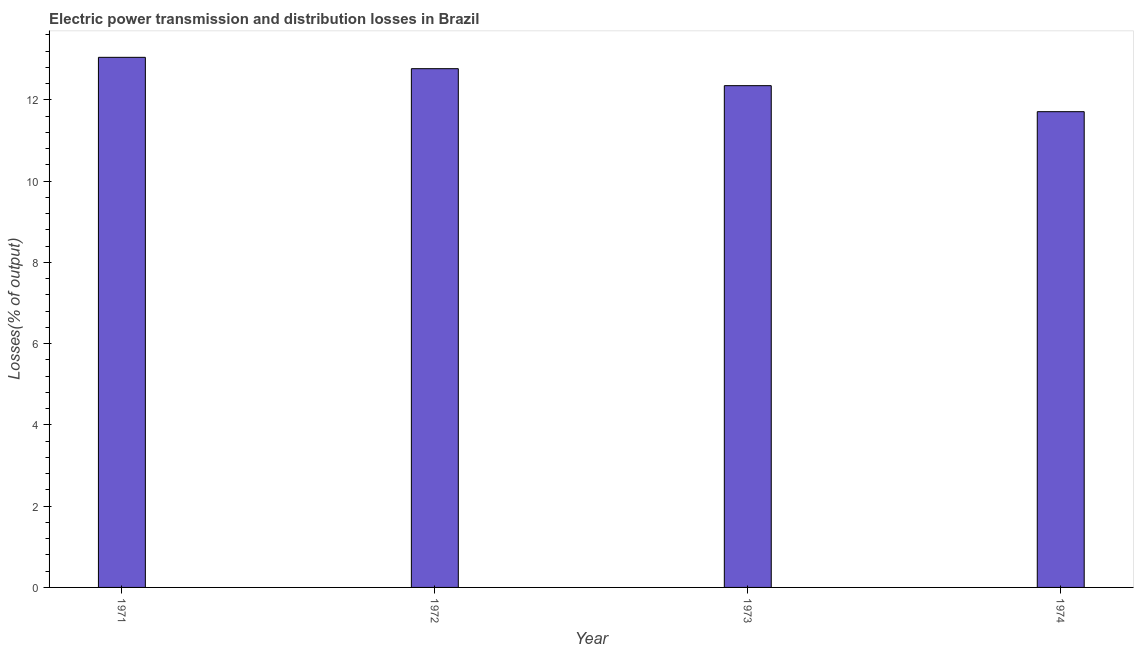Does the graph contain grids?
Your answer should be very brief. No. What is the title of the graph?
Offer a very short reply. Electric power transmission and distribution losses in Brazil. What is the label or title of the X-axis?
Offer a very short reply. Year. What is the label or title of the Y-axis?
Give a very brief answer. Losses(% of output). What is the electric power transmission and distribution losses in 1972?
Offer a very short reply. 12.77. Across all years, what is the maximum electric power transmission and distribution losses?
Offer a terse response. 13.05. Across all years, what is the minimum electric power transmission and distribution losses?
Keep it short and to the point. 11.71. In which year was the electric power transmission and distribution losses maximum?
Your answer should be very brief. 1971. In which year was the electric power transmission and distribution losses minimum?
Your answer should be compact. 1974. What is the sum of the electric power transmission and distribution losses?
Offer a very short reply. 49.87. What is the difference between the electric power transmission and distribution losses in 1971 and 1972?
Make the answer very short. 0.28. What is the average electric power transmission and distribution losses per year?
Your answer should be very brief. 12.47. What is the median electric power transmission and distribution losses?
Give a very brief answer. 12.56. In how many years, is the electric power transmission and distribution losses greater than 7.2 %?
Keep it short and to the point. 4. What is the ratio of the electric power transmission and distribution losses in 1972 to that in 1974?
Offer a terse response. 1.09. Is the difference between the electric power transmission and distribution losses in 1971 and 1974 greater than the difference between any two years?
Keep it short and to the point. Yes. What is the difference between the highest and the second highest electric power transmission and distribution losses?
Ensure brevity in your answer.  0.28. What is the difference between the highest and the lowest electric power transmission and distribution losses?
Ensure brevity in your answer.  1.34. How many bars are there?
Your answer should be very brief. 4. Are the values on the major ticks of Y-axis written in scientific E-notation?
Make the answer very short. No. What is the Losses(% of output) of 1971?
Keep it short and to the point. 13.05. What is the Losses(% of output) in 1972?
Make the answer very short. 12.77. What is the Losses(% of output) of 1973?
Make the answer very short. 12.35. What is the Losses(% of output) of 1974?
Provide a succinct answer. 11.71. What is the difference between the Losses(% of output) in 1971 and 1972?
Your answer should be compact. 0.28. What is the difference between the Losses(% of output) in 1971 and 1973?
Your response must be concise. 0.7. What is the difference between the Losses(% of output) in 1971 and 1974?
Your answer should be very brief. 1.34. What is the difference between the Losses(% of output) in 1972 and 1973?
Give a very brief answer. 0.42. What is the difference between the Losses(% of output) in 1972 and 1974?
Ensure brevity in your answer.  1.06. What is the difference between the Losses(% of output) in 1973 and 1974?
Your answer should be compact. 0.64. What is the ratio of the Losses(% of output) in 1971 to that in 1973?
Ensure brevity in your answer.  1.06. What is the ratio of the Losses(% of output) in 1971 to that in 1974?
Make the answer very short. 1.11. What is the ratio of the Losses(% of output) in 1972 to that in 1973?
Give a very brief answer. 1.03. What is the ratio of the Losses(% of output) in 1972 to that in 1974?
Keep it short and to the point. 1.09. What is the ratio of the Losses(% of output) in 1973 to that in 1974?
Ensure brevity in your answer.  1.05. 